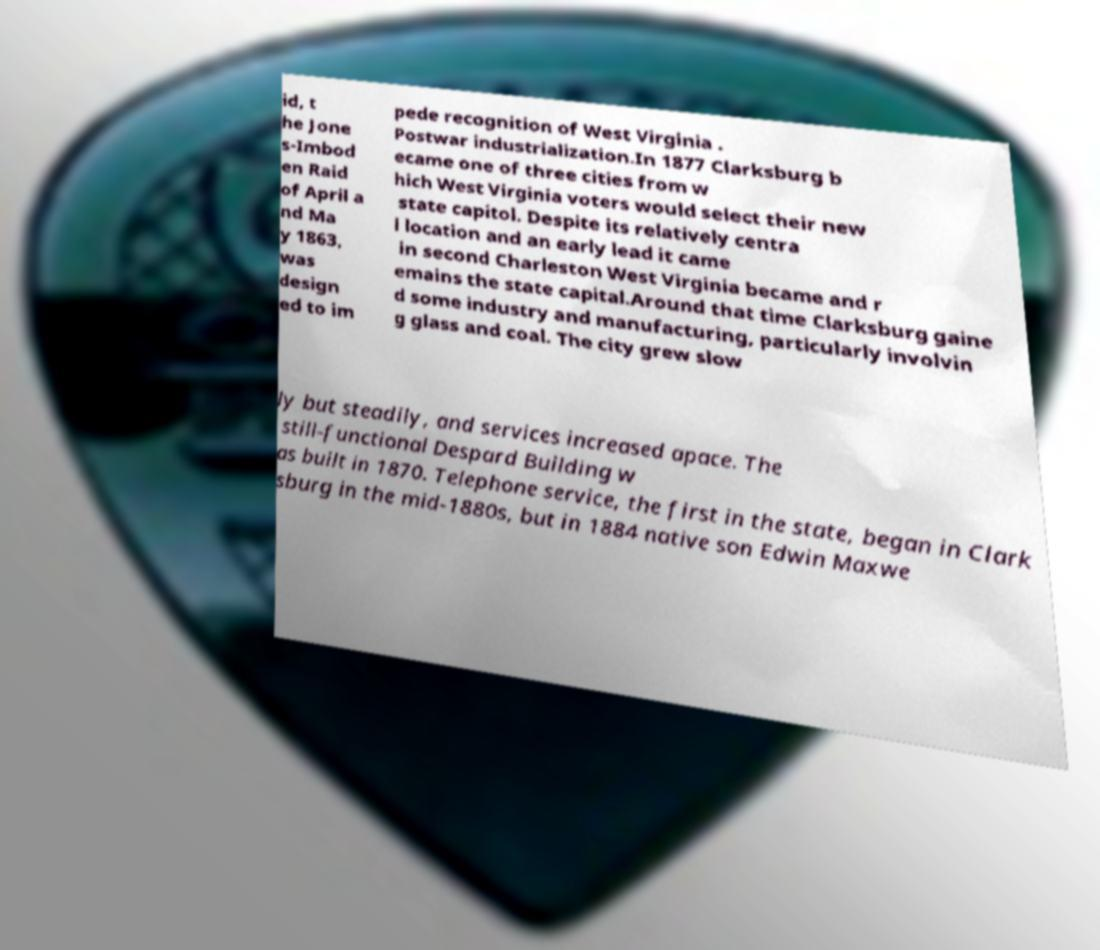There's text embedded in this image that I need extracted. Can you transcribe it verbatim? id, t he Jone s-Imbod en Raid of April a nd Ma y 1863, was design ed to im pede recognition of West Virginia . Postwar industrialization.In 1877 Clarksburg b ecame one of three cities from w hich West Virginia voters would select their new state capitol. Despite its relatively centra l location and an early lead it came in second Charleston West Virginia became and r emains the state capital.Around that time Clarksburg gaine d some industry and manufacturing, particularly involvin g glass and coal. The city grew slow ly but steadily, and services increased apace. The still-functional Despard Building w as built in 1870. Telephone service, the first in the state, began in Clark sburg in the mid-1880s, but in 1884 native son Edwin Maxwe 